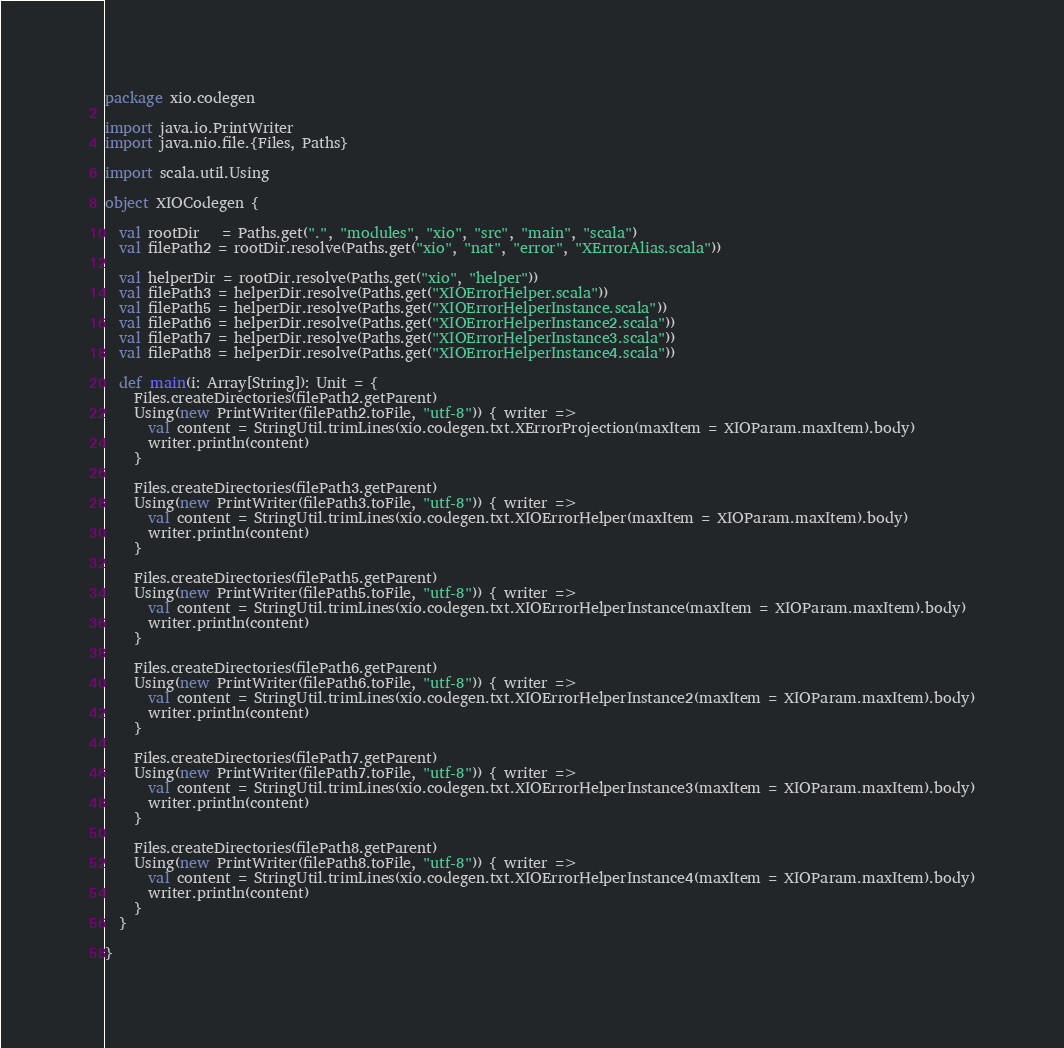<code> <loc_0><loc_0><loc_500><loc_500><_Scala_>package xio.codegen

import java.io.PrintWriter
import java.nio.file.{Files, Paths}

import scala.util.Using

object XIOCodegen {

  val rootDir   = Paths.get(".", "modules", "xio", "src", "main", "scala")
  val filePath2 = rootDir.resolve(Paths.get("xio", "nat", "error", "XErrorAlias.scala"))

  val helperDir = rootDir.resolve(Paths.get("xio", "helper"))
  val filePath3 = helperDir.resolve(Paths.get("XIOErrorHelper.scala"))
  val filePath5 = helperDir.resolve(Paths.get("XIOErrorHelperInstance.scala"))
  val filePath6 = helperDir.resolve(Paths.get("XIOErrorHelperInstance2.scala"))
  val filePath7 = helperDir.resolve(Paths.get("XIOErrorHelperInstance3.scala"))
  val filePath8 = helperDir.resolve(Paths.get("XIOErrorHelperInstance4.scala"))

  def main(i: Array[String]): Unit = {
    Files.createDirectories(filePath2.getParent)
    Using(new PrintWriter(filePath2.toFile, "utf-8")) { writer =>
      val content = StringUtil.trimLines(xio.codegen.txt.XErrorProjection(maxItem = XIOParam.maxItem).body)
      writer.println(content)
    }

    Files.createDirectories(filePath3.getParent)
    Using(new PrintWriter(filePath3.toFile, "utf-8")) { writer =>
      val content = StringUtil.trimLines(xio.codegen.txt.XIOErrorHelper(maxItem = XIOParam.maxItem).body)
      writer.println(content)
    }

    Files.createDirectories(filePath5.getParent)
    Using(new PrintWriter(filePath5.toFile, "utf-8")) { writer =>
      val content = StringUtil.trimLines(xio.codegen.txt.XIOErrorHelperInstance(maxItem = XIOParam.maxItem).body)
      writer.println(content)
    }

    Files.createDirectories(filePath6.getParent)
    Using(new PrintWriter(filePath6.toFile, "utf-8")) { writer =>
      val content = StringUtil.trimLines(xio.codegen.txt.XIOErrorHelperInstance2(maxItem = XIOParam.maxItem).body)
      writer.println(content)
    }

    Files.createDirectories(filePath7.getParent)
    Using(new PrintWriter(filePath7.toFile, "utf-8")) { writer =>
      val content = StringUtil.trimLines(xio.codegen.txt.XIOErrorHelperInstance3(maxItem = XIOParam.maxItem).body)
      writer.println(content)
    }

    Files.createDirectories(filePath8.getParent)
    Using(new PrintWriter(filePath8.toFile, "utf-8")) { writer =>
      val content = StringUtil.trimLines(xio.codegen.txt.XIOErrorHelperInstance4(maxItem = XIOParam.maxItem).body)
      writer.println(content)
    }
  }

}
</code> 